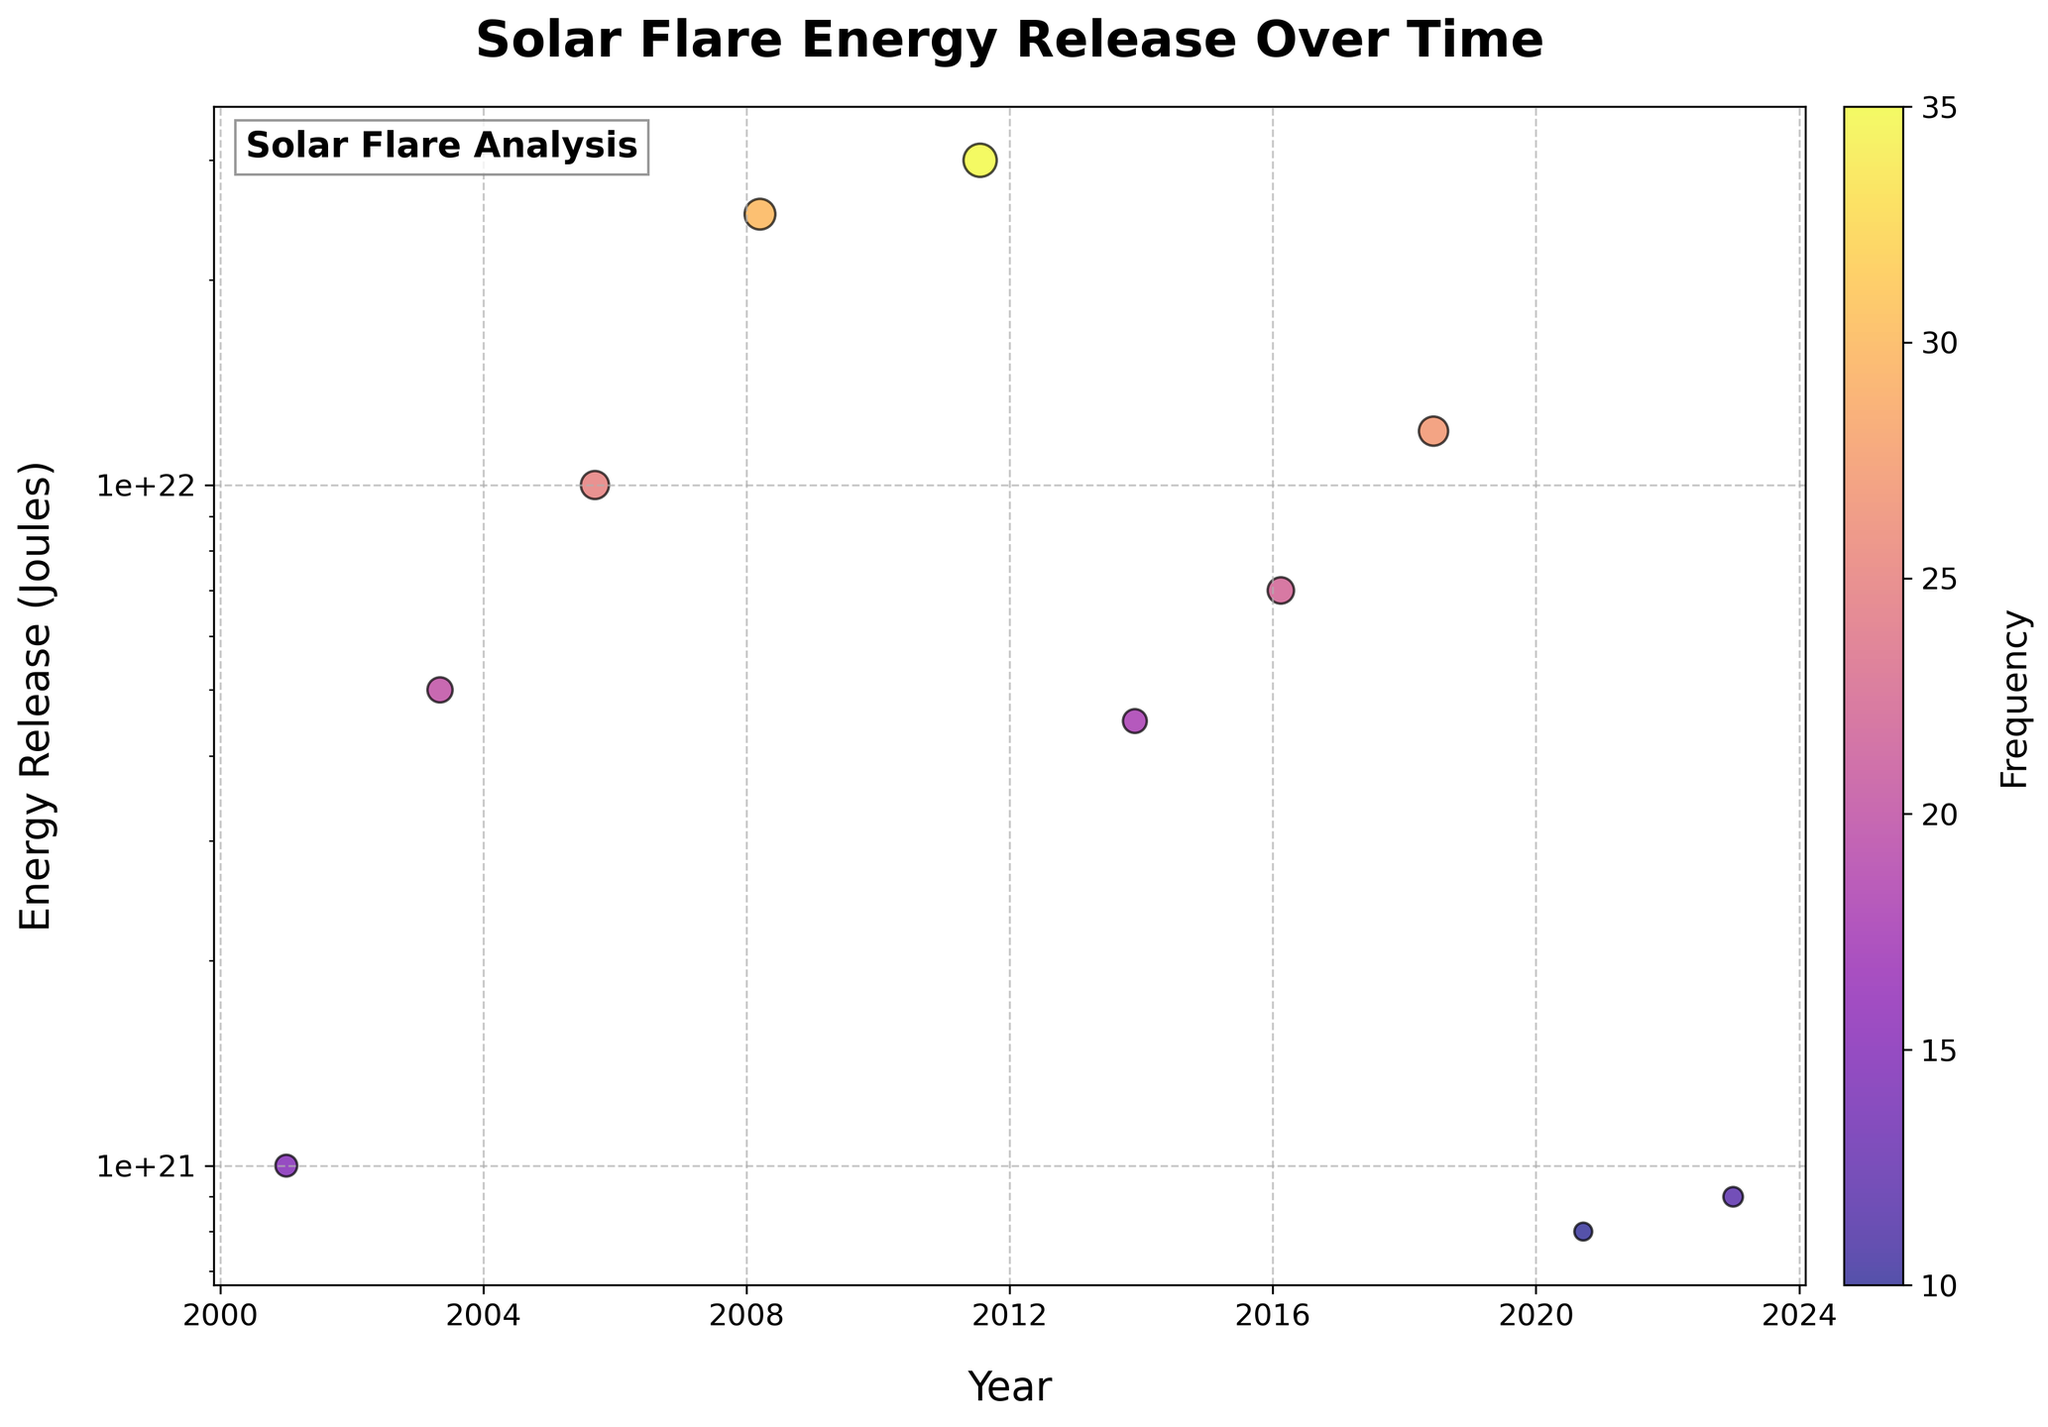What's the title of the plot? The title is written at the top of the plot.
Answer: Solar Flare Energy Release Over Time What do the colors of the scatter points represent? The color bar beside the plot indicates the color corresponds to the frequency of solar flares.
Answer: Frequency Which data point has the highest energy release? The highest energy release can be found by looking for the point at the top of the log scale y-axis.
Answer: 3.00E+22 Joules in 2011 Between which years did the frequency of solar flares increase the most? Compare the size of the scatter points over time. The frequency increases the most between 2008 and 2011.
Answer: 2008 and 2011 What does the y-axis represent and what is its scale? The y-axis label at the side of the plot indicates it represents energy release in Joules, and it is a logarithmic scale.
Answer: Energy Release (Joules), Log scale Which year had the lowest energy release of solar flares? Identify the point closest to the bottom of the y-axis.
Answer: 2020 How is the frequency of solar flares visually represented in the plot? The frequency is shown through the size of the scatter points; larger points indicate a higher frequency.
Answer: By point size Compare the energy release of solar flares in the years 2003 and 2013 – which year had higher energy release? Compare the y-axis positions of the points for 2003 and 2013.
Answer: 2003 had higher energy release What trend can be observed about the frequency of solar flares over time? Observing the sizes of the scatter points from left to right indicates the general trend.
Answer: Generally increasing until 2011 Which year marks the minimum frequency of solar flares observed, and what's the corresponding energy release? Find the smallest scatter point, and check its position on the axes.
Answer: 2020, 8.00E+20 Joules 